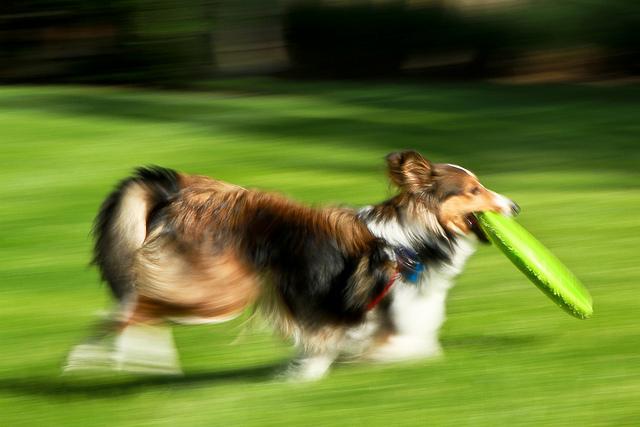Is the dog still?
Short answer required. No. Is the dog a poodle?
Answer briefly. No. What is the dog carrying?
Short answer required. Frisbee. 